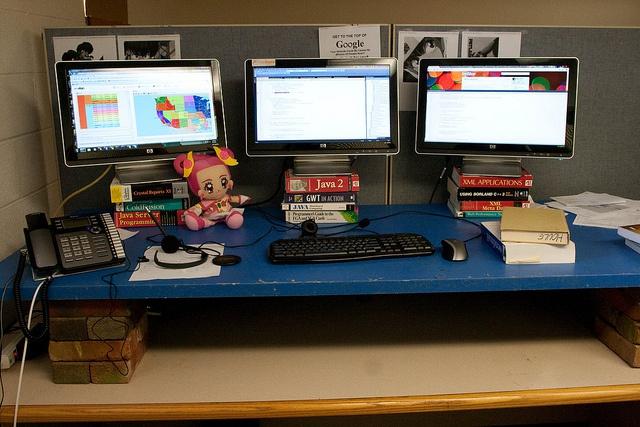Describe the objects in this image and their specific colors. I can see tv in gray, white, black, lightblue, and darkgray tones, tv in gray, white, and black tones, tv in gray, white, black, and darkgray tones, keyboard in gray and black tones, and book in gray, black, and maroon tones in this image. 